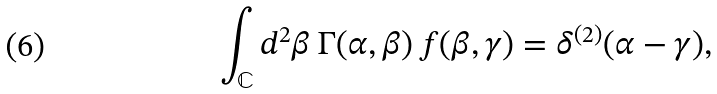<formula> <loc_0><loc_0><loc_500><loc_500>\int _ { \mathbb { C } } d ^ { 2 } \beta \, \Gamma ( \alpha , \beta ) \, f ( \beta , \gamma ) = \delta ^ { ( 2 ) } ( \alpha - \gamma ) ,</formula> 